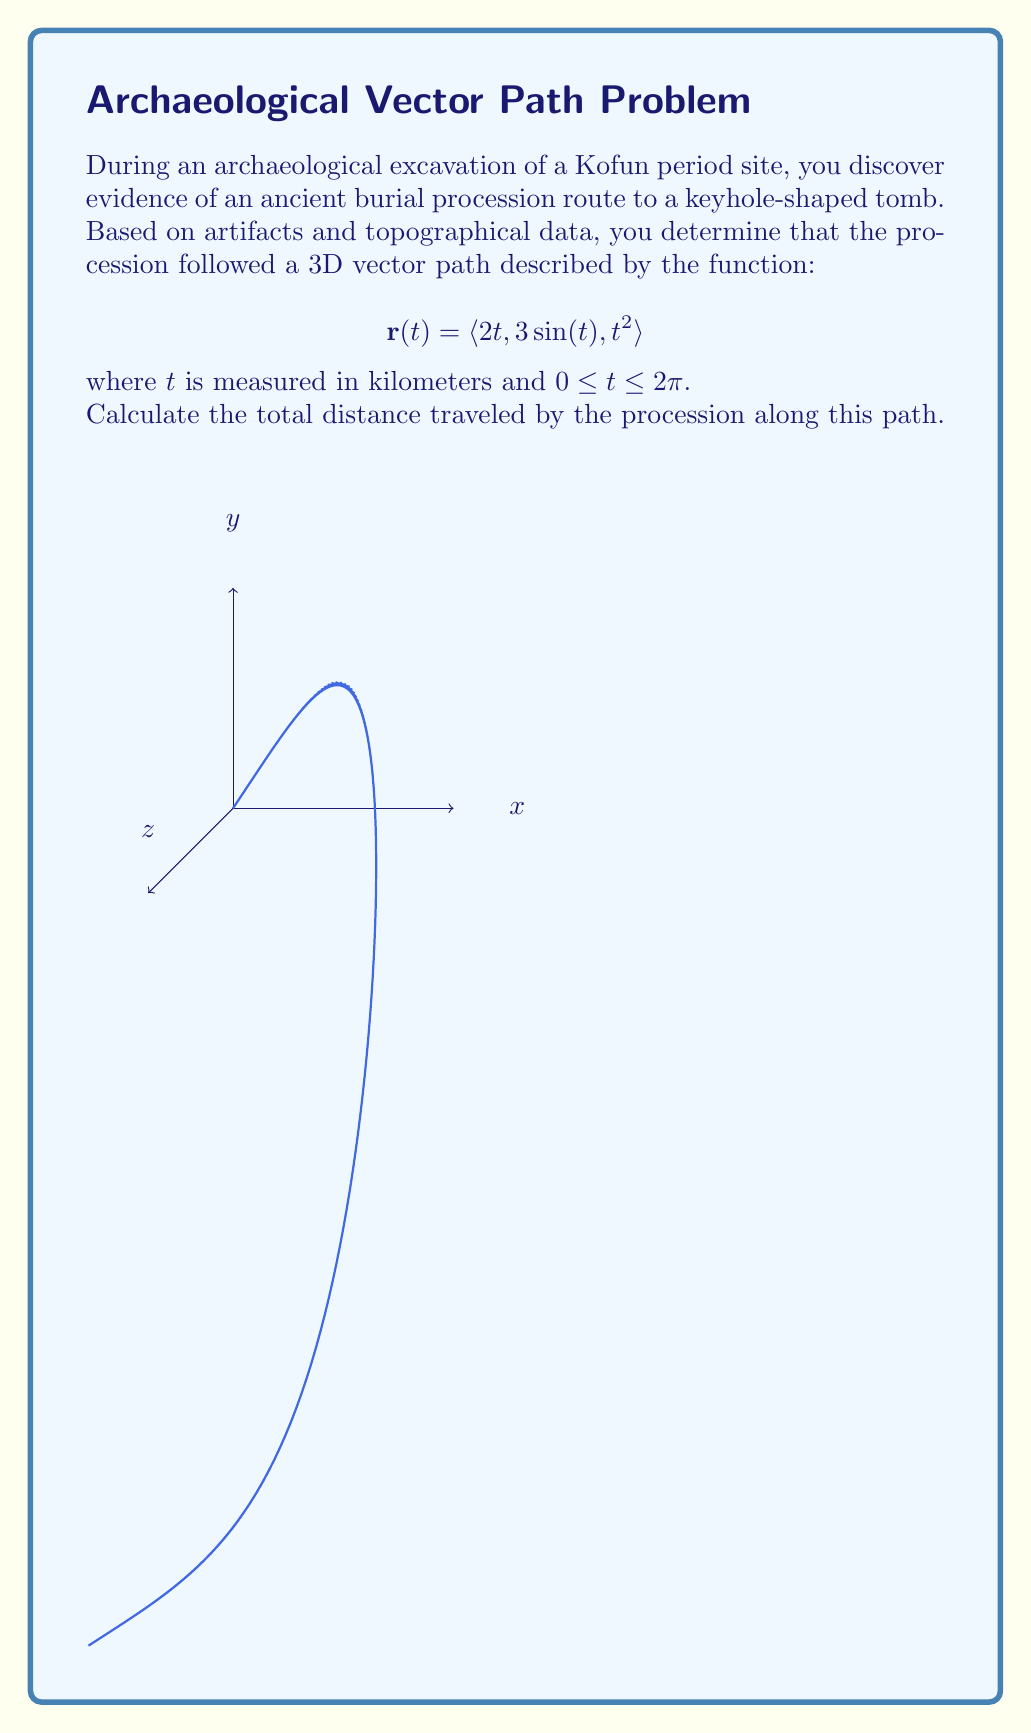Could you help me with this problem? To find the total distance traveled along the vector path, we need to calculate the arc length of the curve. The steps are as follows:

1) The arc length formula for a vector-valued function is:

   $$L = \int_{a}^{b} |\mathbf{r}'(t)| dt$$

2) First, we need to find $\mathbf{r}'(t)$:
   
   $$\mathbf{r}'(t) = \langle 2, 3\cos(t), 2t \rangle$$

3) Now, we calculate $|\mathbf{r}'(t)|$:

   $$|\mathbf{r}'(t)| = \sqrt{(2)^2 + (3\cos(t))^2 + (2t)^2}$$
   $$= \sqrt{4 + 9\cos^2(t) + 4t^2}$$

4) Substituting this into the arc length formula:

   $$L = \int_{0}^{2\pi} \sqrt{4 + 9\cos^2(t) + 4t^2} dt$$

5) This integral cannot be evaluated analytically. We need to use numerical integration methods to approximate the result.

6) Using a numerical integration method (such as Simpson's rule or a computer algebra system), we find that the approximate value of this integral is about 20.35 km.
Answer: $20.35$ km (approximate) 